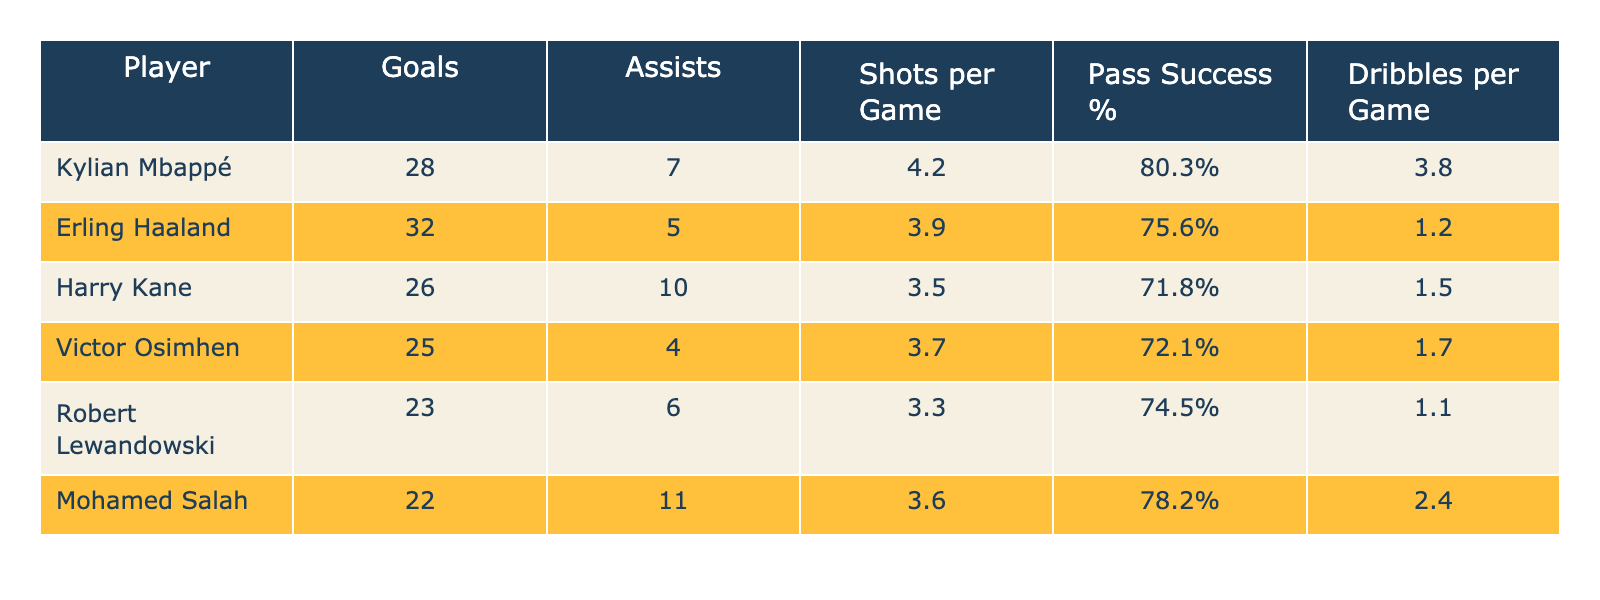What's the total number of goals scored by all players? The total number of goals is calculated by adding up each player's goals: (28 + 32 + 26 + 25 + 23 + 22) = 156.
Answer: 156 Which player has the highest pass success percentage? By reviewing the table, Kylian Mbappé has a pass success percentage of 80.3%, which is the highest among all players.
Answer: Kylian Mbappé What is the average number of assists among the players? To find the average assists, add all the assists together: (7 + 5 + 10 + 4 + 6 + 11) = 43. Then divide by the number of players (6): 43 / 6 = 7.17.
Answer: 7.17 Which player has the lowest shots per game? Looking at the shots per game column, Robert Lewandowski has the lowest value of 3.3 shots per game.
Answer: Robert Lewandowski Is it true that Erling Haaland has more assists than Victor Osimhen? Erling Haaland has 5 assists, while Victor Osimhen has only 4 assists. Therefore, the statement is true.
Answer: True What is the difference in goals between the player with the most goals and the player with the least? The player with the most goals is Erling Haaland with 32 goals, and the player with the least is Robert Lewandowski with 23 goals. The difference is 32 - 23 = 9.
Answer: 9 Which player has the highest average of dribbles per game? By checking the dribbles per game column, Kylian Mbappé has the highest average of 3.8 dribbles per game.
Answer: Kylian Mbappé How many players have a pass success percentage greater than 75%? The players are Kylian Mbappé (80.3%), Mohamed Salah (78.2%), and Erling Haaland (75.6%). That makes it a total of 3 players.
Answer: 3 What is the total number of shots taken by all players in the league? To find the total, we multiply each player’s shots per game by the number of players (assuming the table lists their performance for the same number of games, say 'n'). First, sum up their shots: (4.2 + 3.9 + 3.5 + 3.7 + 3.3 + 3.6) = 22.2 shots. Total would be 22.2n (if n is the same).
Answer: 22.2n Which player has the highest number of assists combined with their goals? We add the goals and assists for each player: Kylian Mbappé (28 + 7 = 35), Erling Haaland (32 + 5 = 37), Harry Kane (26 + 10 = 36), Victor Osimhen (25 + 4 = 29), Robert Lewandowski (23 + 6 = 29), and Mohamed Salah (22 + 11 = 33). Erling Haaland has the highest total with 37.
Answer: Erling Haaland 